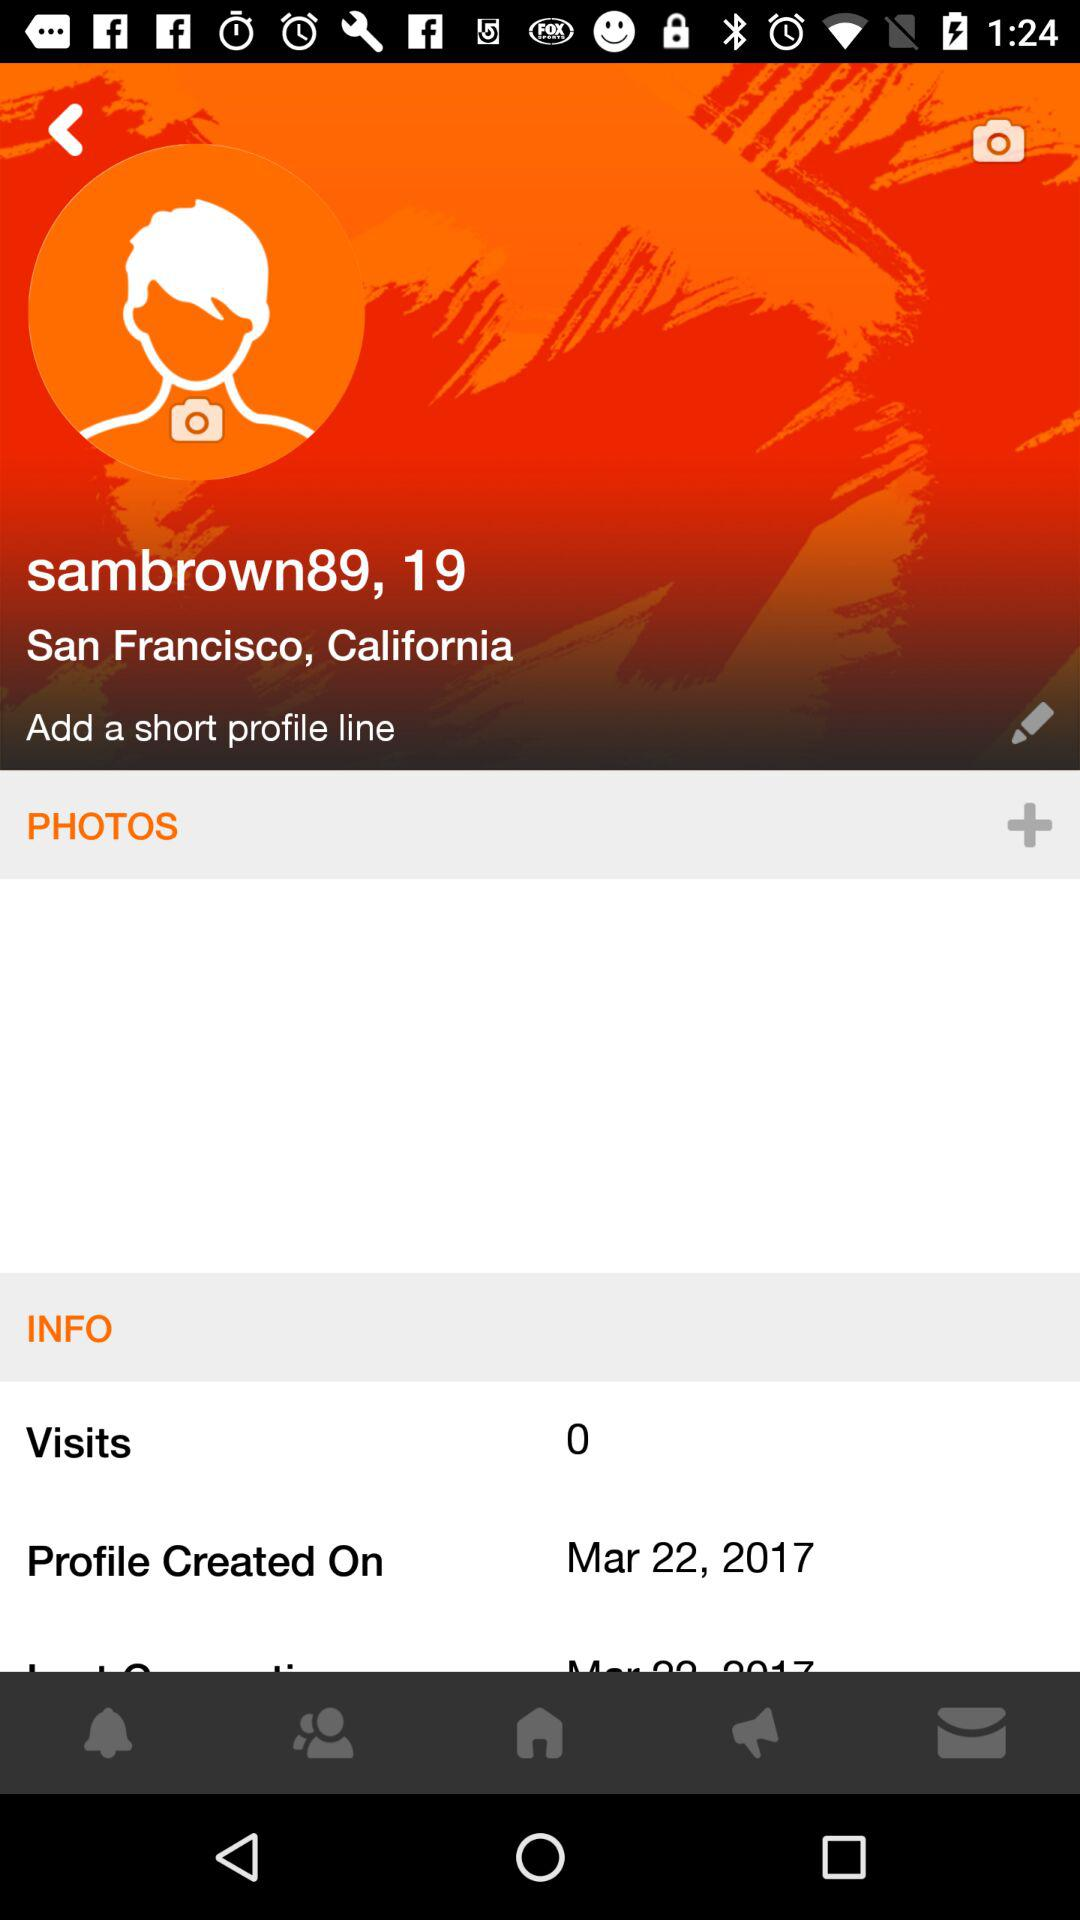What's the username? The user name is "sambrown89". 